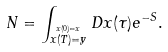Convert formula to latex. <formula><loc_0><loc_0><loc_500><loc_500>N = \int _ { \stackrel { x ( 0 ) = x } { x ( T ) = y } } D x ( \tau ) e ^ { - S } .</formula> 